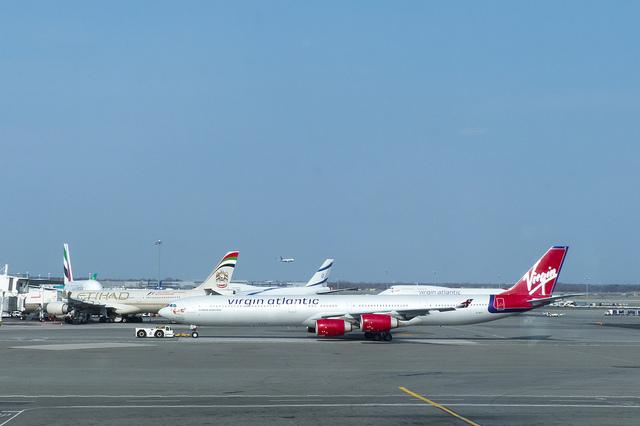How many engines does the nearest plane have?
Be succinct. 2. Which way is the plane in the foreground facing?
Keep it brief. Left. What is the brand of the 2nd plane behind the 1st plane?
Concise answer only. Etihad. 